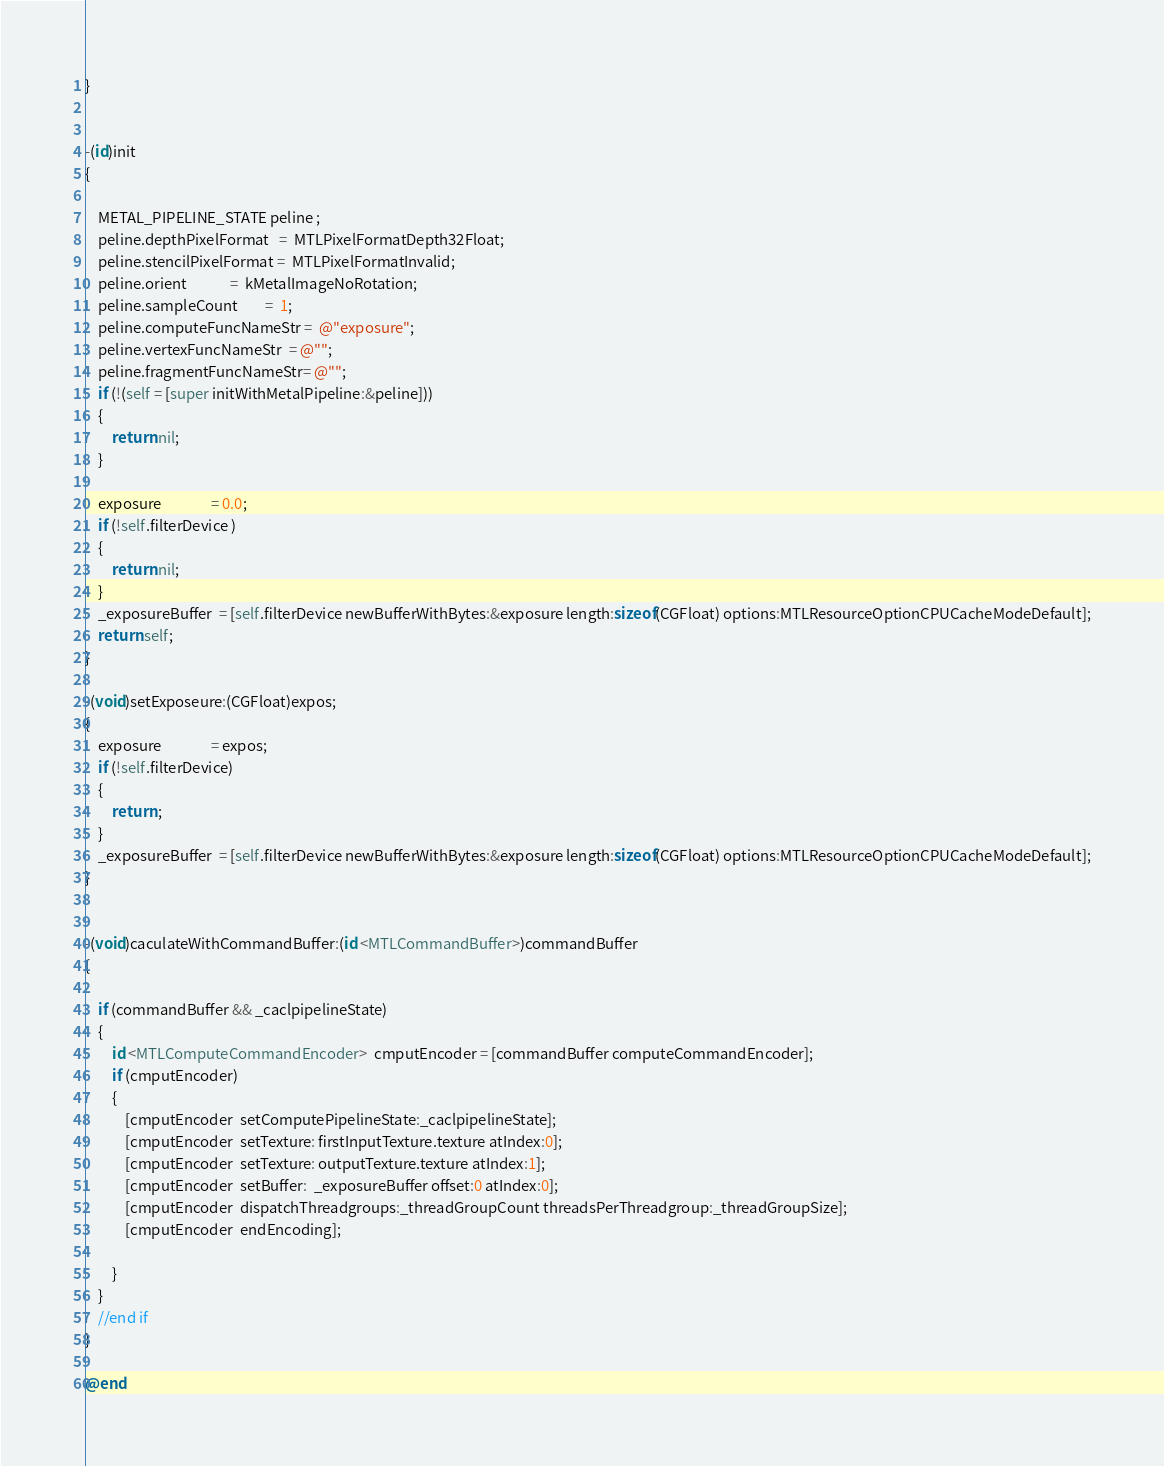<code> <loc_0><loc_0><loc_500><loc_500><_ObjectiveC_>}


-(id)init
{
    
    METAL_PIPELINE_STATE peline ;
    peline.depthPixelFormat   =  MTLPixelFormatDepth32Float;
    peline.stencilPixelFormat =  MTLPixelFormatInvalid;
    peline.orient             =  kMetalImageNoRotation;
    peline.sampleCount        =  1;
    peline.computeFuncNameStr =  @"exposure";
    peline.vertexFuncNameStr  = @"";
    peline.fragmentFuncNameStr= @"";
    if (!(self = [super initWithMetalPipeline:&peline]))
    {
        return nil;
    }
    
    exposure               = 0.0;
    if (!self.filterDevice )
    {
        return nil;
    }
    _exposureBuffer  = [self.filterDevice newBufferWithBytes:&exposure length:sizeof(CGFloat) options:MTLResourceOptionCPUCacheModeDefault];
    return self;
}

-(void)setExposeure:(CGFloat)expos;
{
    exposure               = expos;
    if (!self.filterDevice)
    {
        return ;
    }
    _exposureBuffer  = [self.filterDevice newBufferWithBytes:&exposure length:sizeof(CGFloat) options:MTLResourceOptionCPUCacheModeDefault];
}


-(void)caculateWithCommandBuffer:(id <MTLCommandBuffer>)commandBuffer
{
    
    if (commandBuffer && _caclpipelineState)
    {
        id <MTLComputeCommandEncoder>  cmputEncoder = [commandBuffer computeCommandEncoder];
        if (cmputEncoder)
        {
            [cmputEncoder  setComputePipelineState:_caclpipelineState];
            [cmputEncoder  setTexture: firstInputTexture.texture atIndex:0];
            [cmputEncoder  setTexture: outputTexture.texture atIndex:1];
            [cmputEncoder  setBuffer:  _exposureBuffer offset:0 atIndex:0];
            [cmputEncoder  dispatchThreadgroups:_threadGroupCount threadsPerThreadgroup:_threadGroupSize];
            [cmputEncoder  endEncoding];
            
        }
    }
    //end if
}

@end
</code> 